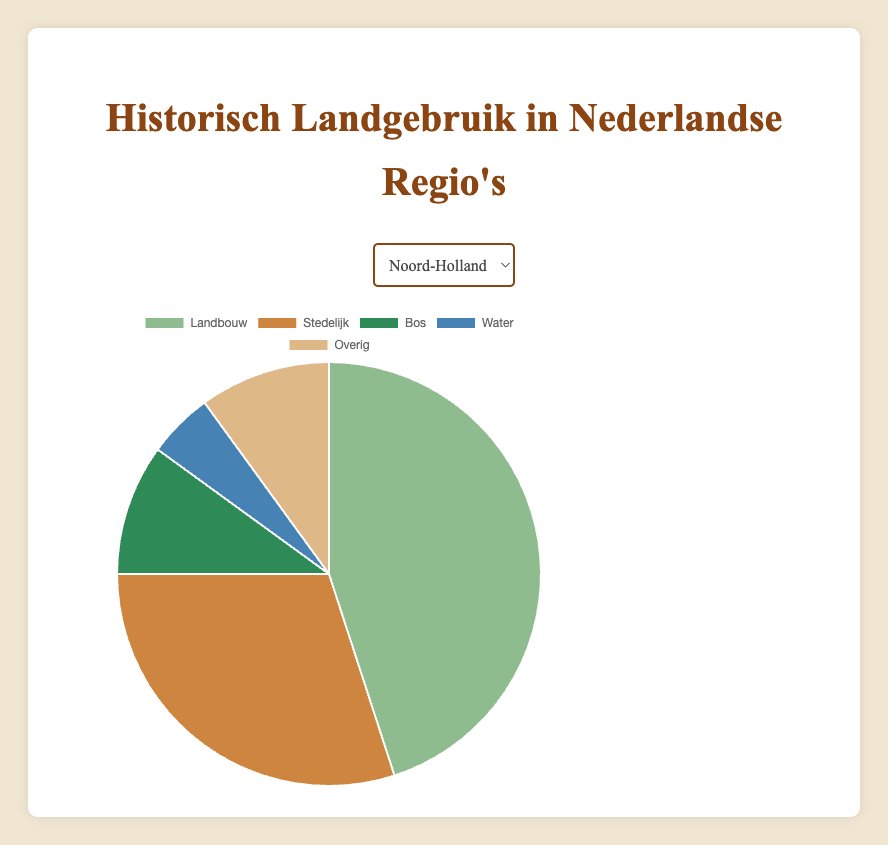Which region has the highest percentage of agricultural land use? Friesland has the highest percentage of agricultural land use at 55%. This can be determined by comparing the agricultural percentages of the five regions (North Holland: 45%, South Holland: 40%, Friesland: 55%, Gelderland: 50%, Utrecht: 35%).
Answer: Friesland Which region has a higher percentage of urban land use, North Holland or Utrecht? North Holland has a higher percentage of urban land use at 30%, compared to Utrecht's 30%. By comparing the urban land use percentages of both regions directly, it is evident that North Holland surpasses Utrecht slightly.
Answer: North Holland What is the sum of the percentages of forest and water bodies land use in Gelderland? In Gelderland, the percentage of forest land use is 20% and water bodies land use is 5%. Adding these together: 20% + 5% = 25%.
Answer: 25% Which region has the lowest percentage of forested land, and what is that percentage? Both South Holland and Friesland have the lowest percentage of forested land at 5%. By comparing the forest percentages in each region (North Holland: 10%, South Holland: 5%, Friesland: 5%, Gelderland: 20%, Utrecht: 20%), South Holland and Friesland share the lowest value.
Answer: South Holland and Friesland, 5% What is the difference between the highest and lowest percentages of agricultural land use among the regions? The highest percentage of agricultural land use is in Friesland (55%) and the lowest is in Utrecht (35%). The difference between these values is 55% - 35% = 20%.
Answer: 20% Which region has the greatest variety in land use percentages, based on the range (the difference between the maximum and minimum land use percentages)? Friesland has the greatest variety, as its land use ranges from a maximum of 55% for agricultural land to a minimum of 5% for forest and water bodies. Therefore, the range is 55% - 5% = 50%.
Answer: Friesland Between North Holland and South Holland, which one has a higher combined percentage of urban and water bodies land use? North Holland has urban land use at 30% and water bodies at 5%, for a combined percentage of 30% + 5% = 35%. South Holland has urban land use at 35% and water bodies at 10%, for a combined percentage of 35% + 10% = 45%. Therefore, South Holland has a higher combined percentage.
Answer: South Holland What is the average percentage of land used for 'other' purposes across all regions? Adding the 'other' land use percentages across all regions (North Holland: 10%, South Holland: 10%, Friesland: 10%, Gelderland: 10%, Utrecht: 10%) results in 50%. Dividing this sum by the number of regions (5) gives us an average of 10%.
Answer: 10% Which region has the smallest percentage difference between urban and agricultural land use? North Holland has a difference of 45% (agricultural) - 30% (urban) = 15%. South Holland has a difference of 40% (agricultural) - 35% (urban) = 5%. Friesland has a difference of 55% (agricultural) - 15% (urban) = 40%. Gelderland has a difference of 50% (agricultural) - 15% (urban) = 35%. Utrecht has a difference of 35% (agricultural) - 30% (urban) = 5%. Thus, both South Holland and Utrecht have the smallest percentage difference of 5%.
Answer: South Holland and Utrecht If we combine the forest and urban land use percentages, which region has the highest combined percentage? North Holland: 10% (forest) + 30% (urban) = 40%, South Holland: 5% (forest) + 35% (urban) = 40%, Friesland: 5% (forest) + 15% (urban) = 20%, Gelderland: 20% (forest) + 15% (urban) = 35%, Utrecht: 20% (forest) + 30% (urban) = 50%. Therefore, Utrecht has the highest combined percentage at 50%.
Answer: Utrecht 